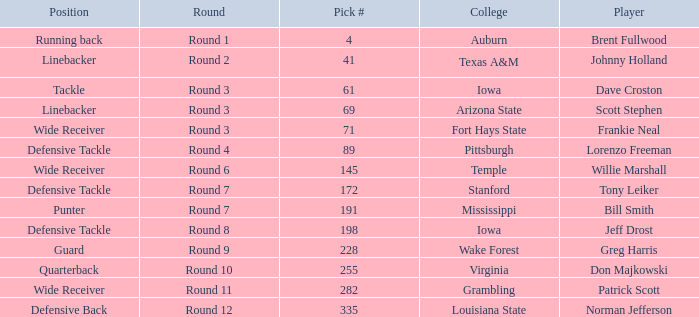What is the sum of pick# for Don Majkowski?3 255.0. 